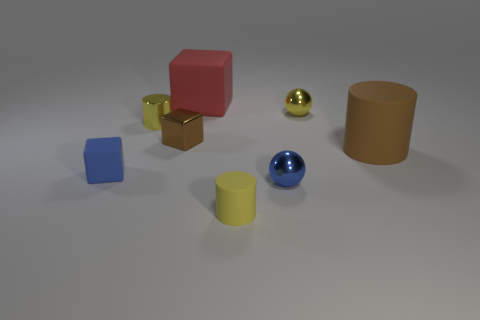Is the number of big matte cubes that are left of the metallic cylinder less than the number of large red matte blocks behind the yellow rubber thing?
Keep it short and to the point. Yes. There is a large rubber thing that is on the right side of the yellow matte cylinder; is its shape the same as the blue rubber thing?
Offer a terse response. No. Do the yellow thing that is to the left of the tiny yellow rubber cylinder and the big brown thing have the same material?
Provide a succinct answer. No. What is the material of the blue object behind the small metal ball in front of the big rubber object that is to the right of the red object?
Make the answer very short. Rubber. How many other objects are there of the same shape as the brown rubber thing?
Make the answer very short. 2. There is a metal ball behind the brown cylinder; what is its color?
Make the answer very short. Yellow. There is a small yellow object on the left side of the cylinder in front of the blue matte cube; how many rubber cylinders are to the left of it?
Give a very brief answer. 0. There is a big thing to the left of the yellow rubber cylinder; what number of brown cylinders are in front of it?
Offer a terse response. 1. How many brown rubber objects are left of the brown metal thing?
Provide a succinct answer. 0. What number of other things are the same size as the blue shiny sphere?
Provide a succinct answer. 5. 